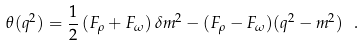<formula> <loc_0><loc_0><loc_500><loc_500>\theta ( q ^ { 2 } ) = \frac { 1 } { 2 } \, ( F _ { \rho } + F _ { \omega } ) \, \delta m ^ { 2 } - ( F _ { \rho } - F _ { \omega } ) ( q ^ { 2 } - m ^ { 2 } ) \ .</formula> 